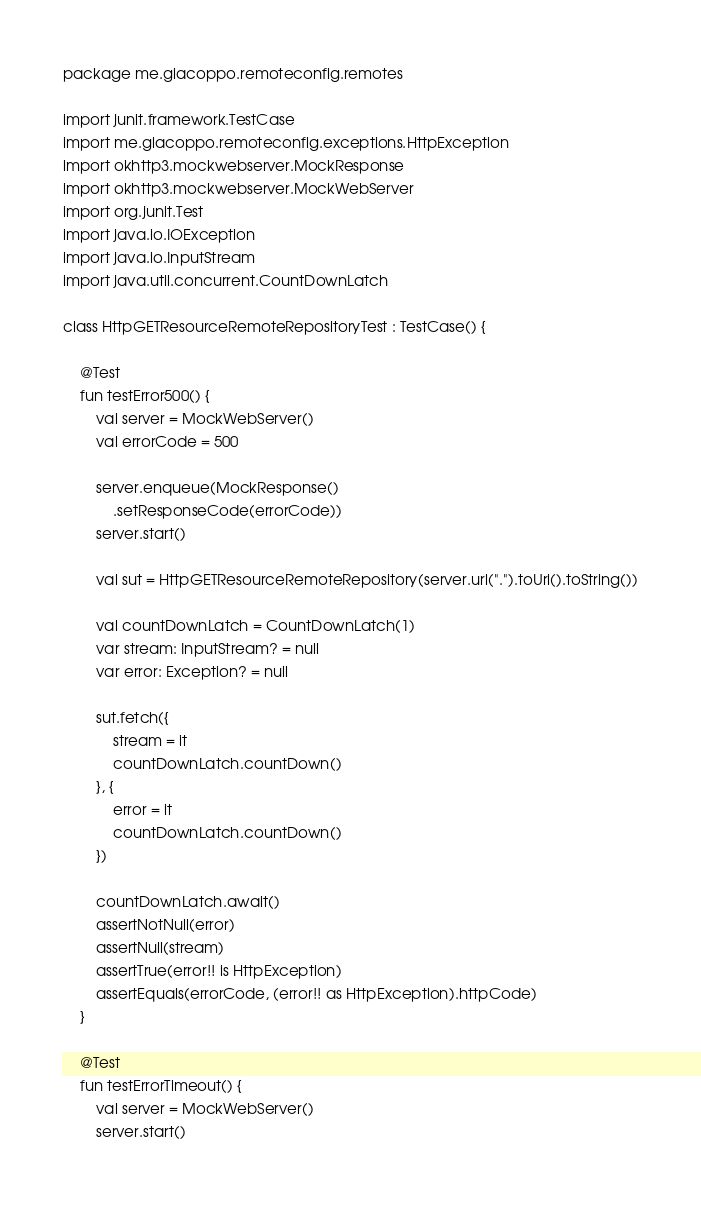Convert code to text. <code><loc_0><loc_0><loc_500><loc_500><_Kotlin_>package me.giacoppo.remoteconfig.remotes

import junit.framework.TestCase
import me.giacoppo.remoteconfig.exceptions.HttpException
import okhttp3.mockwebserver.MockResponse
import okhttp3.mockwebserver.MockWebServer
import org.junit.Test
import java.io.IOException
import java.io.InputStream
import java.util.concurrent.CountDownLatch

class HttpGETResourceRemoteRepositoryTest : TestCase() {

    @Test
    fun testError500() {
        val server = MockWebServer()
        val errorCode = 500

        server.enqueue(MockResponse()
            .setResponseCode(errorCode))
        server.start()

        val sut = HttpGETResourceRemoteRepository(server.url(".").toUri().toString())

        val countDownLatch = CountDownLatch(1)
        var stream: InputStream? = null
        var error: Exception? = null

        sut.fetch({
            stream = it
            countDownLatch.countDown()
        }, {
            error = it
            countDownLatch.countDown()
        })

        countDownLatch.await()
        assertNotNull(error)
        assertNull(stream)
        assertTrue(error!! is HttpException)
        assertEquals(errorCode, (error!! as HttpException).httpCode)
    }

    @Test
    fun testErrorTimeout() {
        val server = MockWebServer()
        server.start()
</code> 